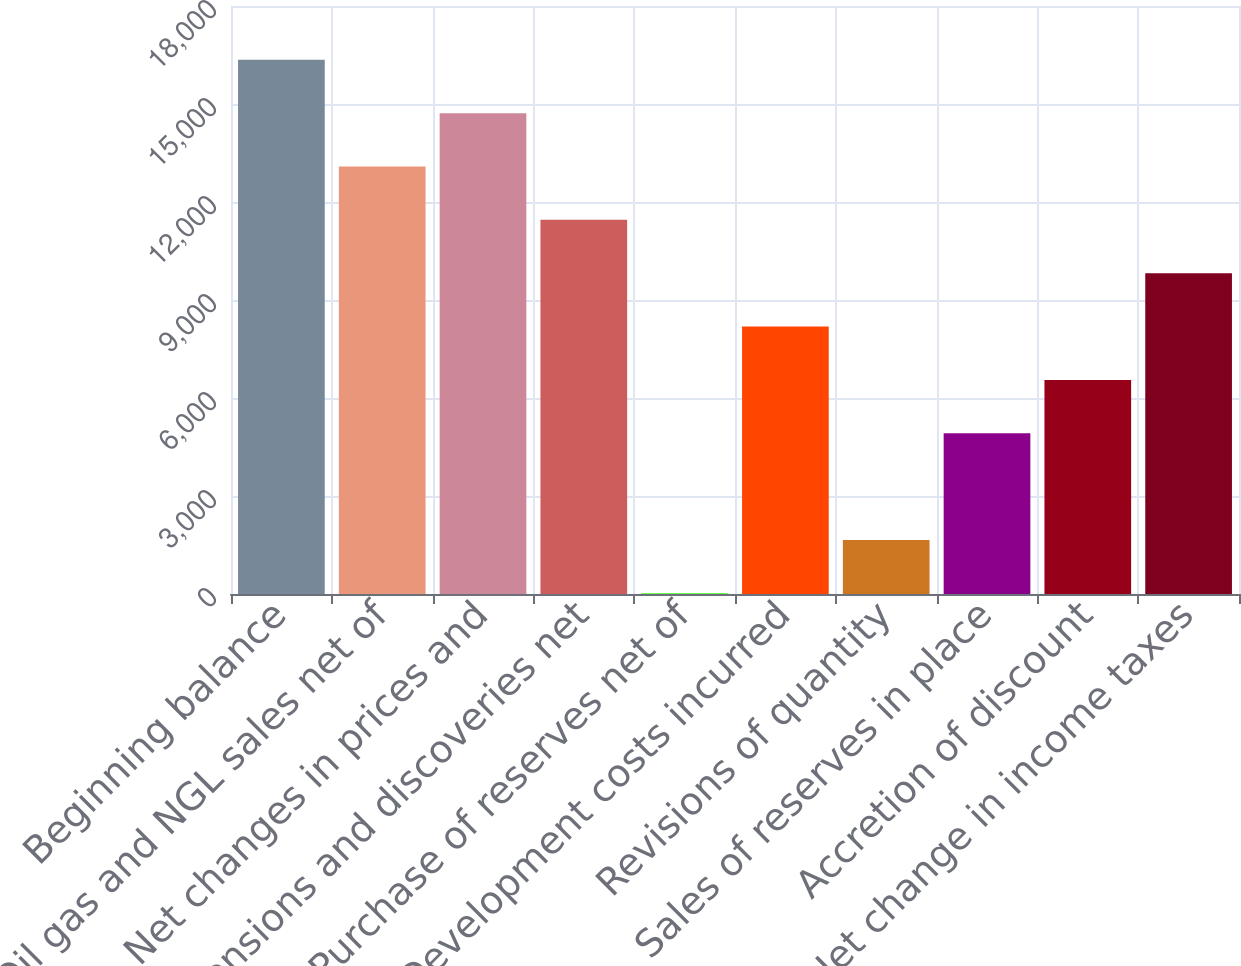<chart> <loc_0><loc_0><loc_500><loc_500><bar_chart><fcel>Beginning balance<fcel>Oil gas and NGL sales net of<fcel>Net changes in prices and<fcel>Extensions and discoveries net<fcel>Purchase of reserves net of<fcel>Development costs incurred<fcel>Revisions of quantity<fcel>Sales of reserves in place<fcel>Accretion of discount<fcel>Net change in income taxes<nl><fcel>16352<fcel>13086.2<fcel>14719.1<fcel>11453.3<fcel>23<fcel>8187.5<fcel>1655.9<fcel>4921.7<fcel>6554.6<fcel>9820.4<nl></chart> 